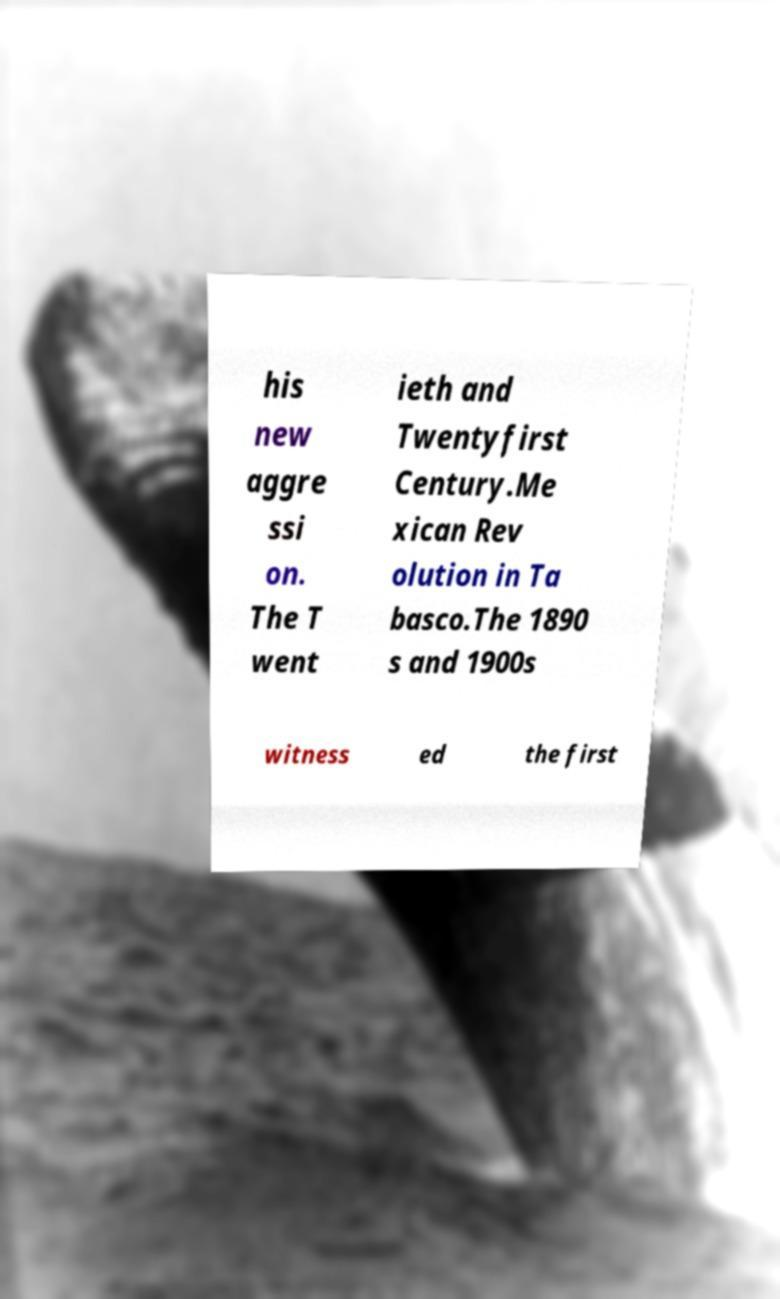I need the written content from this picture converted into text. Can you do that? his new aggre ssi on. The T went ieth and Twentyfirst Century.Me xican Rev olution in Ta basco.The 1890 s and 1900s witness ed the first 